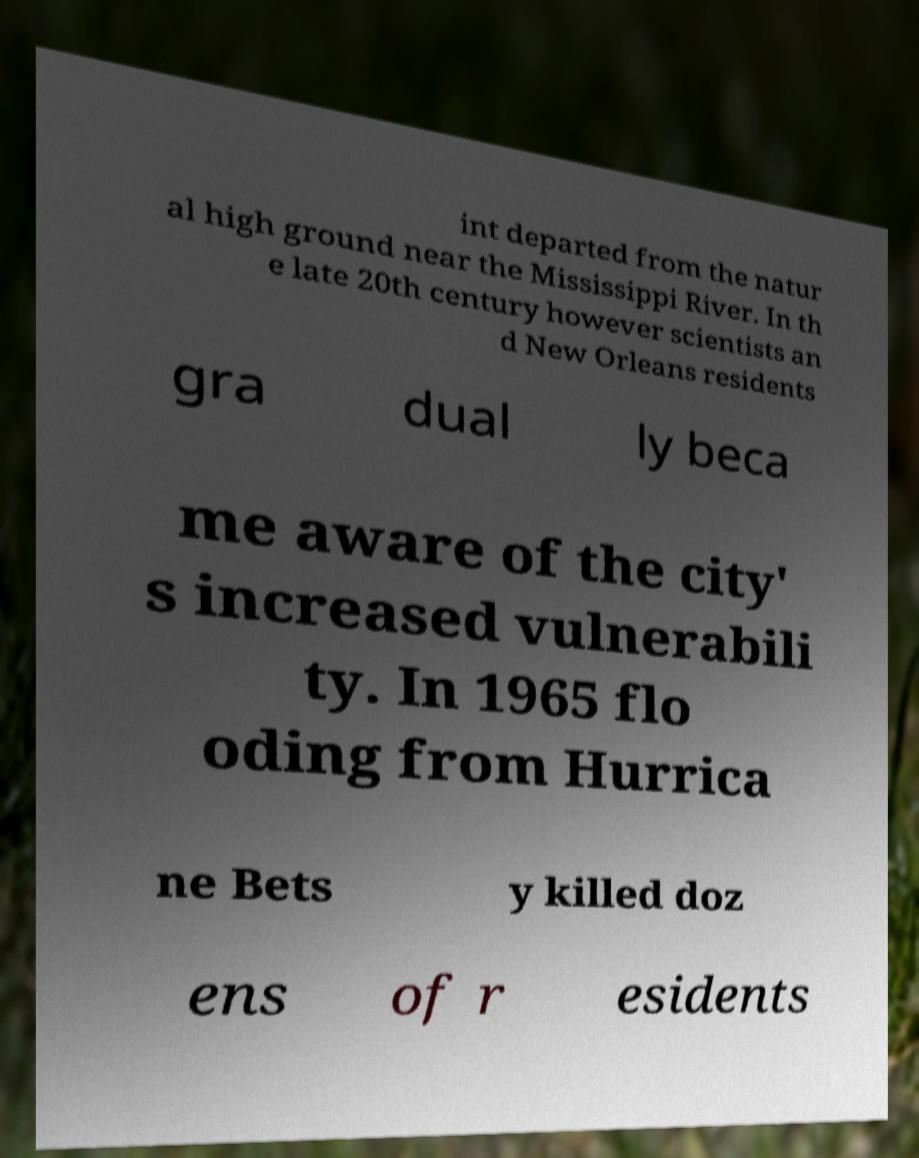There's text embedded in this image that I need extracted. Can you transcribe it verbatim? int departed from the natur al high ground near the Mississippi River. In th e late 20th century however scientists an d New Orleans residents gra dual ly beca me aware of the city' s increased vulnerabili ty. In 1965 flo oding from Hurrica ne Bets y killed doz ens of r esidents 